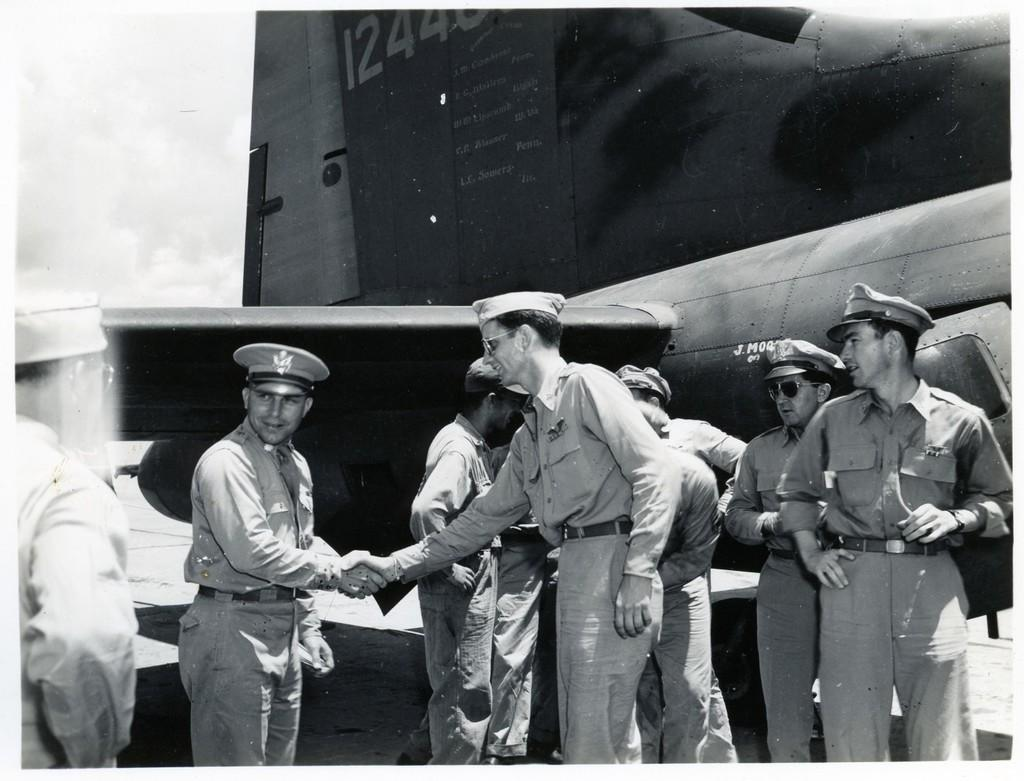<image>
Relay a brief, clear account of the picture shown. Members of the arm forces are standing next to a plane with the numbers 1244 showing. 